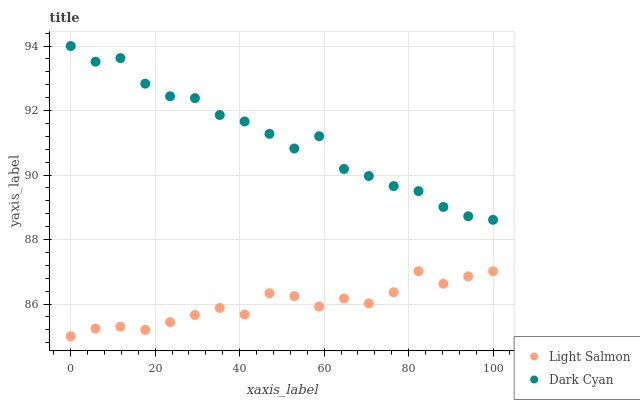Does Light Salmon have the minimum area under the curve?
Answer yes or no. Yes. Does Dark Cyan have the maximum area under the curve?
Answer yes or no. Yes. Does Light Salmon have the maximum area under the curve?
Answer yes or no. No. Is Light Salmon the smoothest?
Answer yes or no. Yes. Is Dark Cyan the roughest?
Answer yes or no. Yes. Is Light Salmon the roughest?
Answer yes or no. No. Does Light Salmon have the lowest value?
Answer yes or no. Yes. Does Dark Cyan have the highest value?
Answer yes or no. Yes. Does Light Salmon have the highest value?
Answer yes or no. No. Is Light Salmon less than Dark Cyan?
Answer yes or no. Yes. Is Dark Cyan greater than Light Salmon?
Answer yes or no. Yes. Does Light Salmon intersect Dark Cyan?
Answer yes or no. No. 